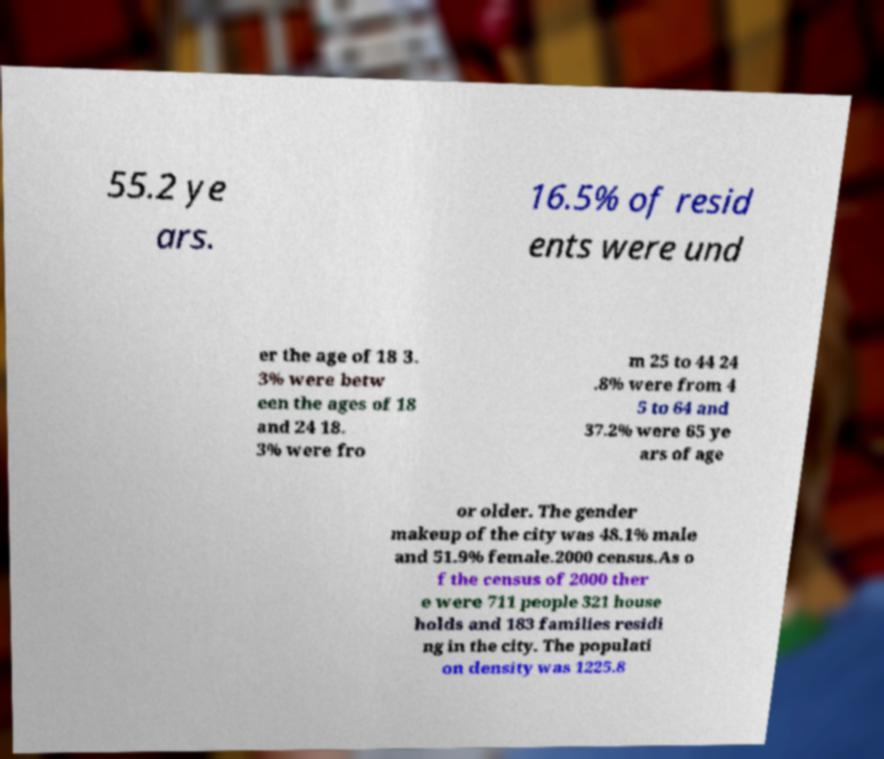Could you assist in decoding the text presented in this image and type it out clearly? 55.2 ye ars. 16.5% of resid ents were und er the age of 18 3. 3% were betw een the ages of 18 and 24 18. 3% were fro m 25 to 44 24 .8% were from 4 5 to 64 and 37.2% were 65 ye ars of age or older. The gender makeup of the city was 48.1% male and 51.9% female.2000 census.As o f the census of 2000 ther e were 711 people 321 house holds and 183 families residi ng in the city. The populati on density was 1225.8 